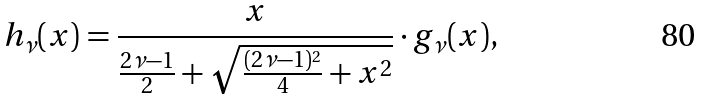Convert formula to latex. <formula><loc_0><loc_0><loc_500><loc_500>h _ { \nu } ( x ) = \frac { x } { \frac { 2 \nu - 1 } { 2 } + \sqrt { \frac { ( 2 \nu - 1 ) ^ { 2 } } { 4 } + x ^ { 2 } } } \cdot g _ { \nu } ( x ) ,</formula> 